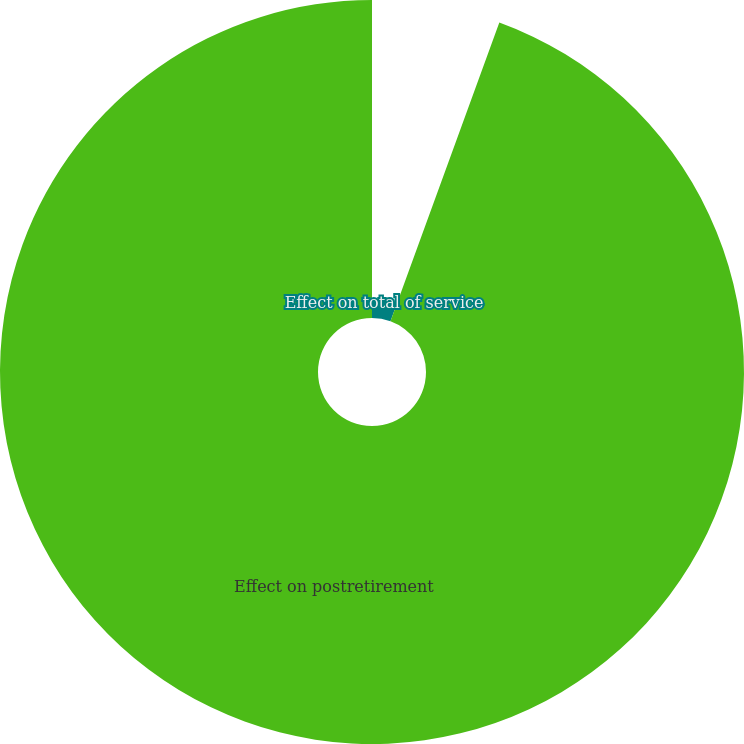Convert chart to OTSL. <chart><loc_0><loc_0><loc_500><loc_500><pie_chart><fcel>Effect on total of service<fcel>Effect on postretirement<nl><fcel>5.56%<fcel>94.44%<nl></chart> 